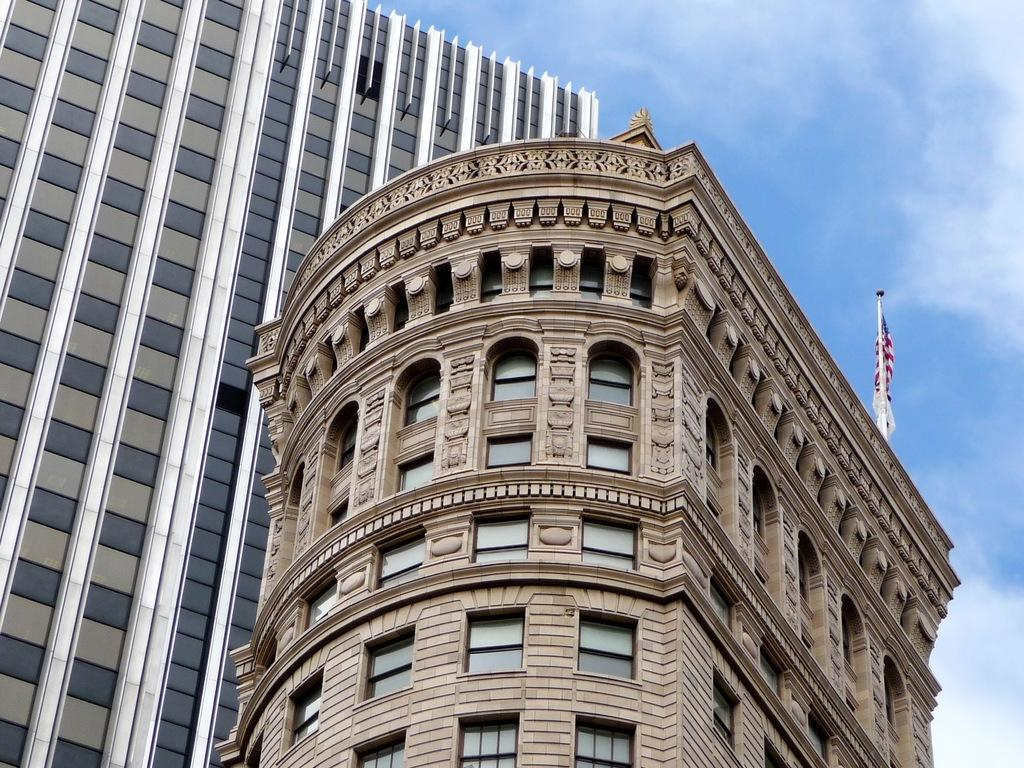How many buildings can be seen in the image? There are two buildings in the image. What feature do the buildings have in common? Both buildings have windows. Where is the flag located in the image? The flag is on the right side of one of the buildings. What is visible at the top of the image? The sky is visible at the top of the image. What statement can be made about the drawer in the image? There is no drawer present in the image. 